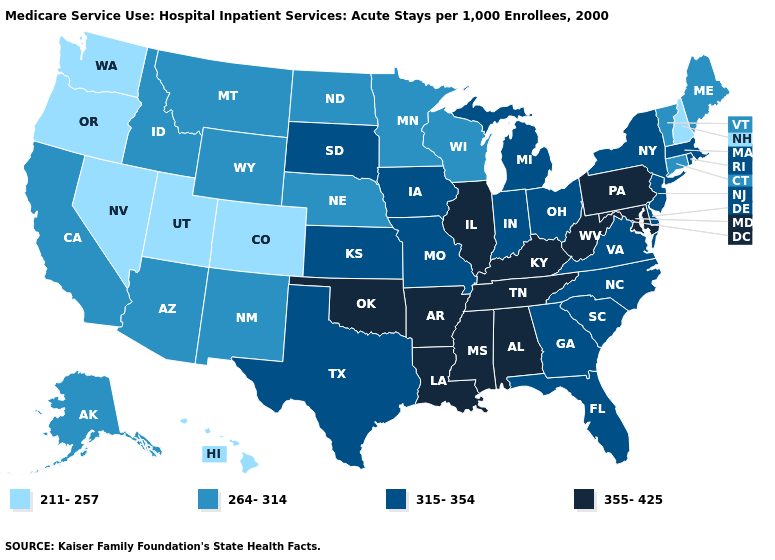What is the lowest value in the MidWest?
Give a very brief answer. 264-314. Name the states that have a value in the range 315-354?
Answer briefly. Delaware, Florida, Georgia, Indiana, Iowa, Kansas, Massachusetts, Michigan, Missouri, New Jersey, New York, North Carolina, Ohio, Rhode Island, South Carolina, South Dakota, Texas, Virginia. Which states hav the highest value in the West?
Concise answer only. Alaska, Arizona, California, Idaho, Montana, New Mexico, Wyoming. What is the value of Wyoming?
Give a very brief answer. 264-314. Does Michigan have the lowest value in the MidWest?
Quick response, please. No. Does New Hampshire have the lowest value in the Northeast?
Give a very brief answer. Yes. What is the highest value in the USA?
Write a very short answer. 355-425. Does New Hampshire have the same value as Minnesota?
Short answer required. No. Which states hav the highest value in the West?
Short answer required. Alaska, Arizona, California, Idaho, Montana, New Mexico, Wyoming. What is the highest value in states that border Maryland?
Keep it brief. 355-425. Name the states that have a value in the range 264-314?
Give a very brief answer. Alaska, Arizona, California, Connecticut, Idaho, Maine, Minnesota, Montana, Nebraska, New Mexico, North Dakota, Vermont, Wisconsin, Wyoming. Which states have the highest value in the USA?
Be succinct. Alabama, Arkansas, Illinois, Kentucky, Louisiana, Maryland, Mississippi, Oklahoma, Pennsylvania, Tennessee, West Virginia. What is the value of Nevada?
Answer briefly. 211-257. What is the highest value in the MidWest ?
Short answer required. 355-425. What is the value of Arkansas?
Write a very short answer. 355-425. 